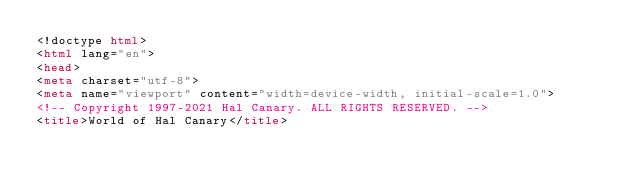Convert code to text. <code><loc_0><loc_0><loc_500><loc_500><_HTML_><!doctype html>
<html lang="en">
<head>
<meta charset="utf-8">
<meta name="viewport" content="width=device-width, initial-scale=1.0">
<!-- Copyright 1997-2021 Hal Canary. ALL RIGHTS RESERVED. -->
<title>World of Hal Canary</title></code> 